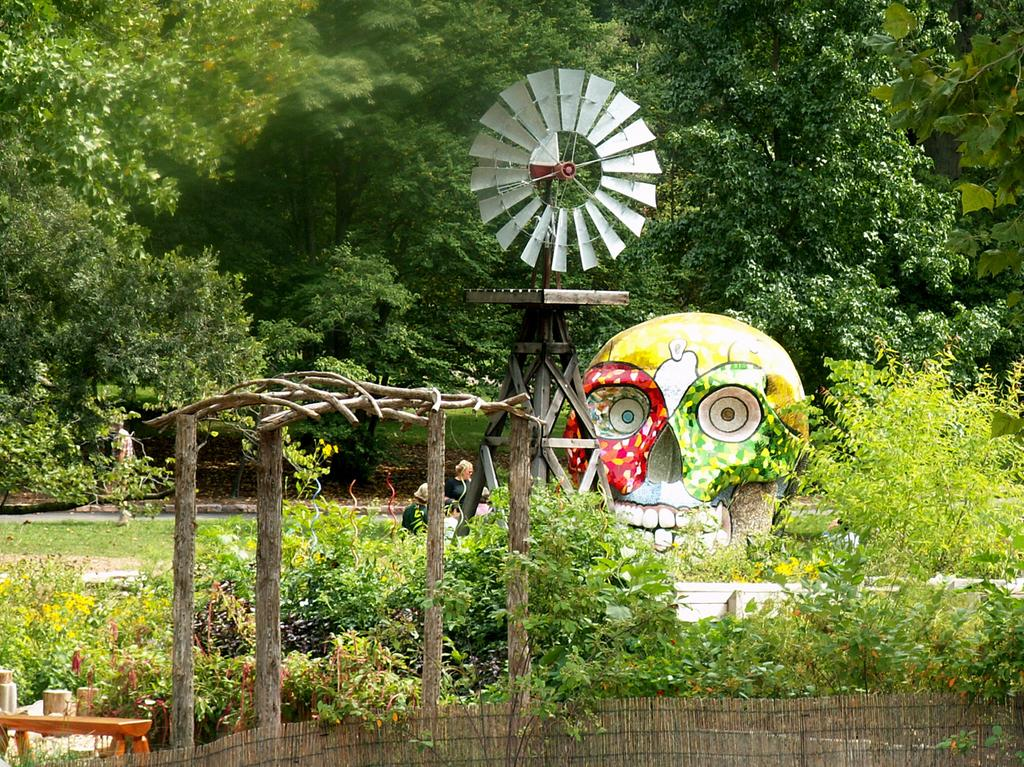What types of vegetation can be seen in the image? There are multiple plants and trees in the image. Can you describe any other objects or structures in the image? There is a red and green color skull and a windmill in the image. Are there any people present in the image? Yes, there are people visible in the image. What type of grain is being blown by the windmill in the image? There is no windmill blowing grain in the image; the windmill is a separate structure. 